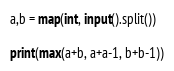<code> <loc_0><loc_0><loc_500><loc_500><_Python_>a,b = map(int, input().split())

print(max(a+b, a+a-1, b+b-1))</code> 